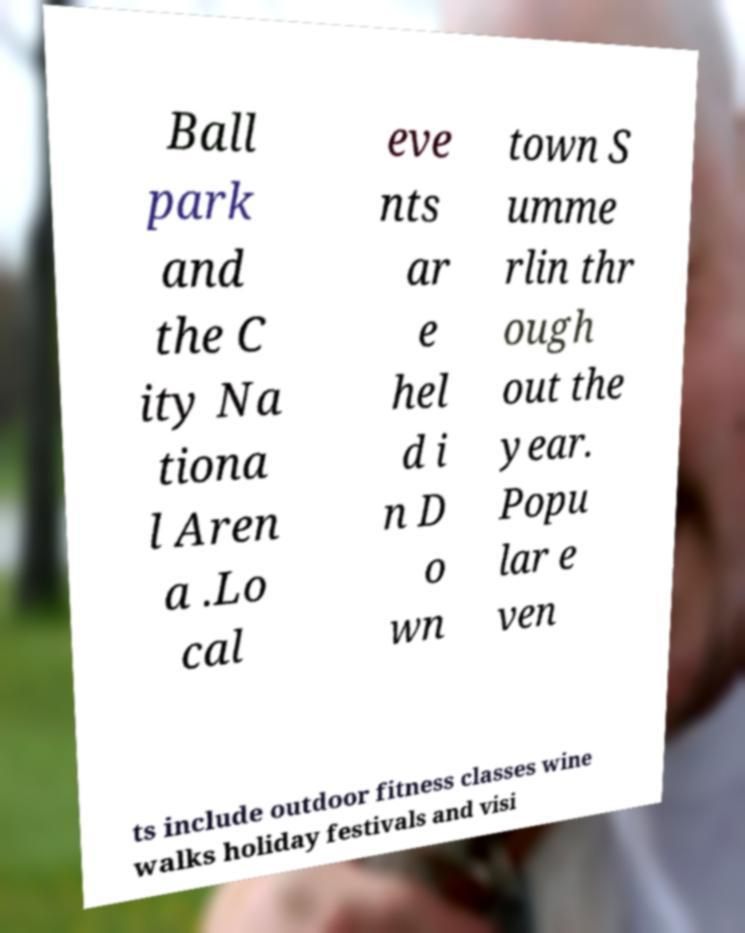There's text embedded in this image that I need extracted. Can you transcribe it verbatim? Ball park and the C ity Na tiona l Aren a .Lo cal eve nts ar e hel d i n D o wn town S umme rlin thr ough out the year. Popu lar e ven ts include outdoor fitness classes wine walks holiday festivals and visi 